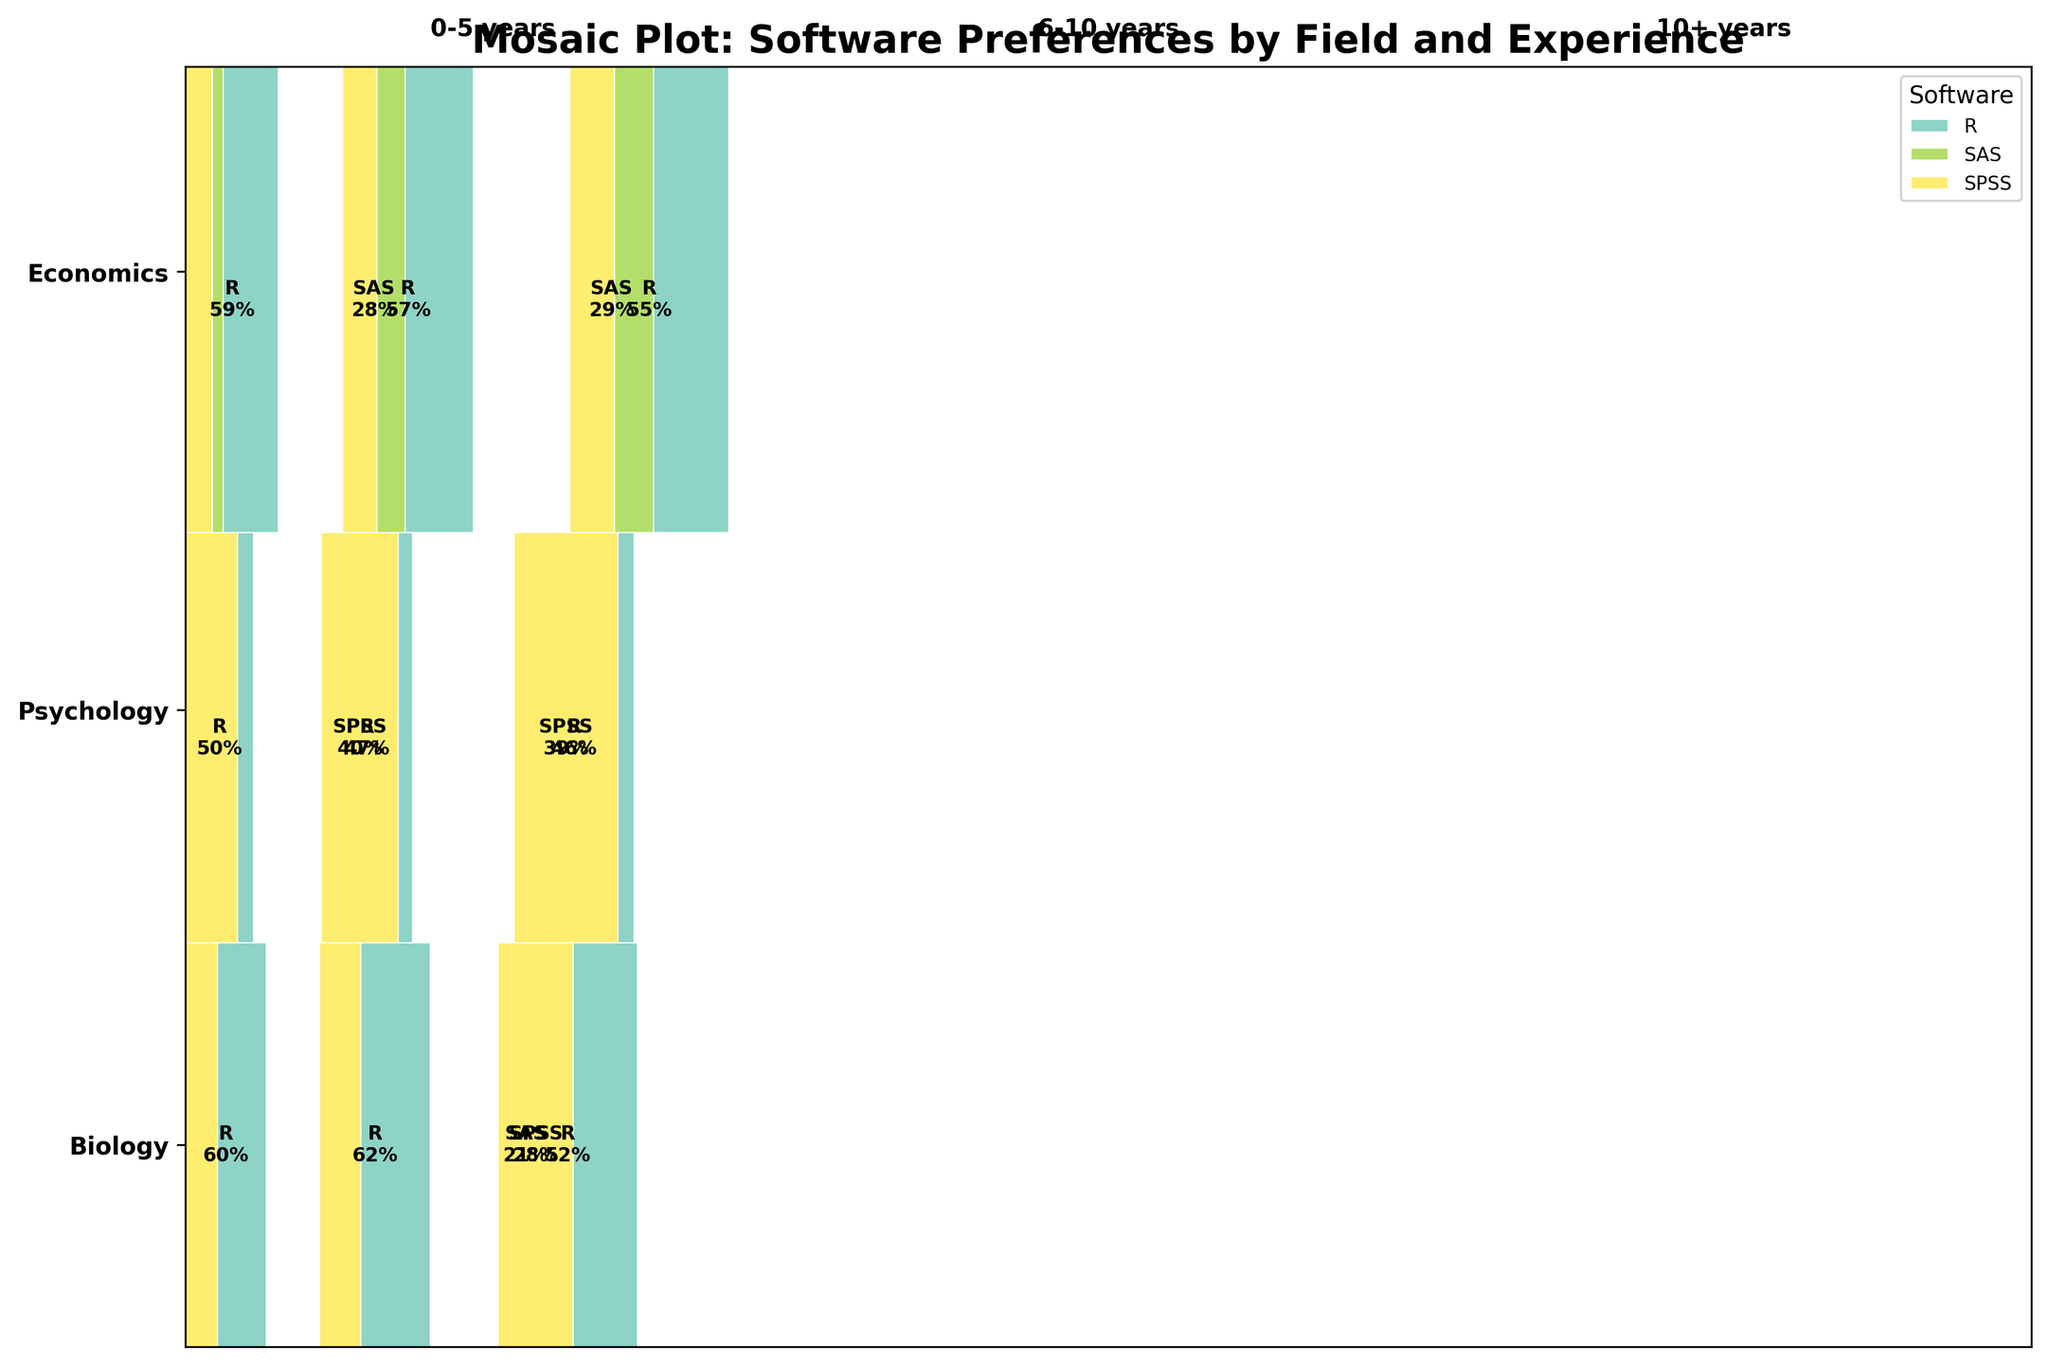what is the title of the plot? The title of the plot is usually positioned at the top of the figure. By looking at the top of the figure, you can see the text that serves as the title.
Answer: Mosaic Plot: Software Preferences by Field and Experience What are the three fields represented in the plot? The fields are listed along the y-axis of the plot, typically labeled or marked at different vertical positions in the figure. They can be identified by their distinct labeled areas.
Answer: Biology, Psychology, Economics What software has the highest proportion in the 'Biology' field with 10+ years of experience? The proportion of users in each software category is represented by the width of the rectangles. In the 'Biology' field with 10+ years of experience, we can compare the widths of rectangles for each software type.
Answer: R Which field shows the greatest variety in software preferences, and how might this be visually identifiable? The variety in software preferences can be assessed by the distribution and spread of different colored rectangles within each field. The field with the most evenly distributed and varied rectangle widths indicates greater variety.
Answer: Psychology Compare the usage of 'R' among researchers with 0-5 years of experience in 'Biology' and 'Economics' fields. Which field has a higher proportion? The widths of the colored rectangles for 'R' in the 0-5 years experience group in 'Biology' and 'Economics' need to be compared. The wider width signifies a higher proportion.
Answer: Economics What is the most preferred software among researchers in the 'Psychology' field with 0-5 years of experience? By examining the different colored rectangles in the 'Psychology' field for 0-5 years of experience, we can identify the largest rectangle which indicates the preferred software.
Answer: SPSS In the 'Economics' field, which software has the lowest usage among researchers with 10+ years of experience? To find this, we observe the smallest rectangle in the 'Economics' field for the group with 10+ years of experience.
Answer: SPSS Which software shows an increase in usage as experience increases in the 'Biology' field? By examining the widths of rectangles for each software in the 'Biology' field across different levels of experience, the software with increasing rectangle widths indicates increasing usage.
Answer: R How does the software preference in 'Psychology' contrast between researchers with 0-5 years and 10+ years of experience? Comparison involves contrasting the distribution of different software rectangles for 0-5 years and 10+ years of experience in the 'Psychology' field. By comparing their widths for each experience group, we can see which software becomes more or less preferred.
Answer: R usage increases, SPSS preference is significant throughout What insight can you infer about 'SAS' usage across all fields and experience levels? Observing the distribution and width of 'SAS' rectangles across all fields and experience levels shows a consistent trend or pattern. Narrower rectangles suggest lower usage.
Answer: SAS is consistently less preferred across all categories 